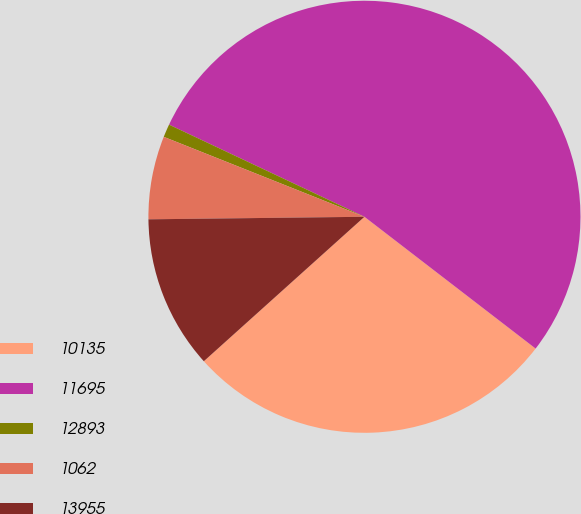Convert chart to OTSL. <chart><loc_0><loc_0><loc_500><loc_500><pie_chart><fcel>10135<fcel>11695<fcel>12893<fcel>1062<fcel>13955<nl><fcel>27.9%<fcel>53.43%<fcel>0.98%<fcel>6.22%<fcel>11.47%<nl></chart> 